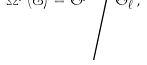Convert formula to latex. <formula><loc_0><loc_0><loc_500><loc_500>\Omega ^ { p } ( \mathcal { E } ) = \Theta ^ { p } \Big / \Theta ^ { p } _ { \ell } ,</formula> 